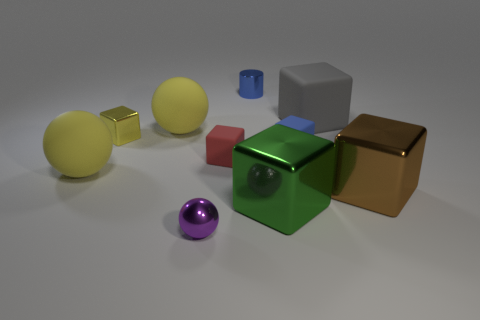How many other objects are the same color as the small sphere?
Offer a terse response. 0. What is the material of the yellow object that is the same shape as the red thing?
Give a very brief answer. Metal. There is a small object left of the purple ball; what is its shape?
Your response must be concise. Cube. How many other big brown metal objects are the same shape as the brown thing?
Your answer should be compact. 0. Is the number of metal cubes that are right of the tiny red matte object the same as the number of gray things that are in front of the gray rubber thing?
Provide a short and direct response. No. Are there any objects that have the same material as the small yellow cube?
Your answer should be compact. Yes. Is the material of the brown thing the same as the gray object?
Your answer should be very brief. No. How many yellow objects are either small matte things or large objects?
Provide a short and direct response. 2. Is the number of tiny red blocks that are behind the small blue cylinder greater than the number of red spheres?
Ensure brevity in your answer.  No. Is there a object of the same color as the cylinder?
Your response must be concise. Yes. 